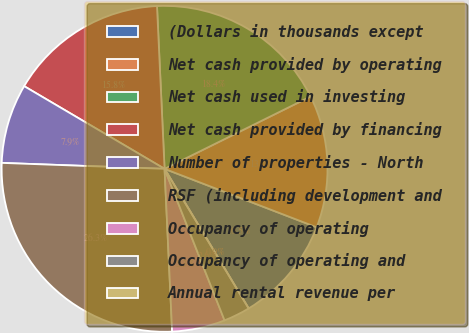<chart> <loc_0><loc_0><loc_500><loc_500><pie_chart><fcel>(Dollars in thousands except<fcel>Net cash provided by operating<fcel>Net cash used in investing<fcel>Net cash provided by financing<fcel>Number of properties - North<fcel>RSF (including development and<fcel>Occupancy of operating<fcel>Occupancy of operating and<fcel>Annual rental revenue per<nl><fcel>10.53%<fcel>13.16%<fcel>18.42%<fcel>15.79%<fcel>7.89%<fcel>26.32%<fcel>5.26%<fcel>2.63%<fcel>0.0%<nl></chart> 